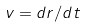<formula> <loc_0><loc_0><loc_500><loc_500>v = d r / d t</formula> 